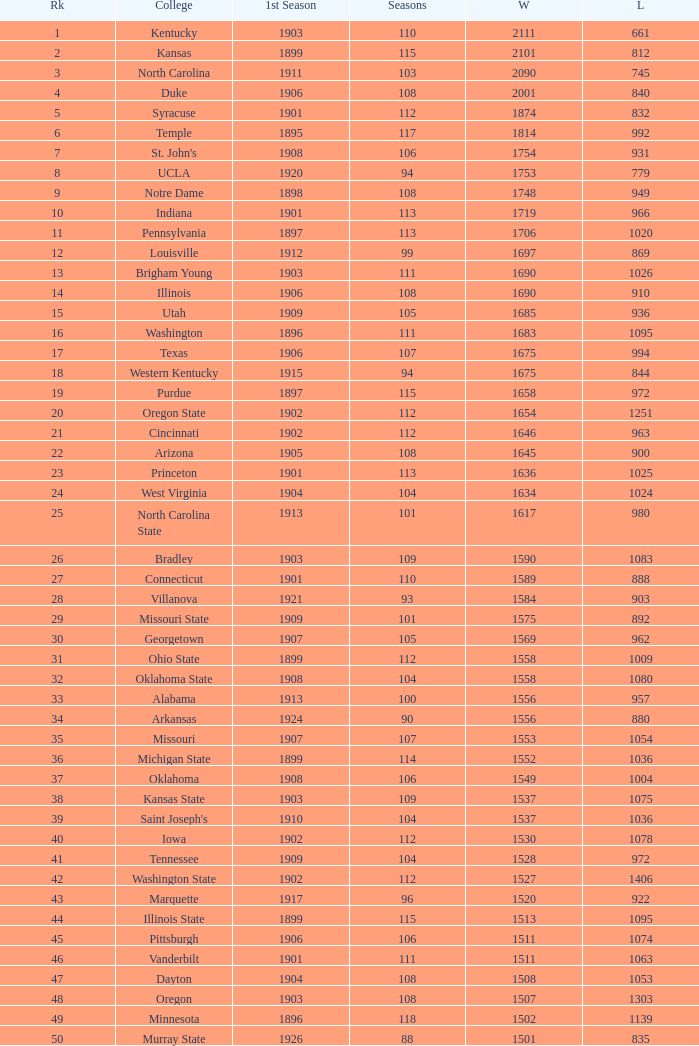How many wins were there for Washington State College with losses greater than 980 and a first season before 1906 and rank greater than 42? 0.0. 